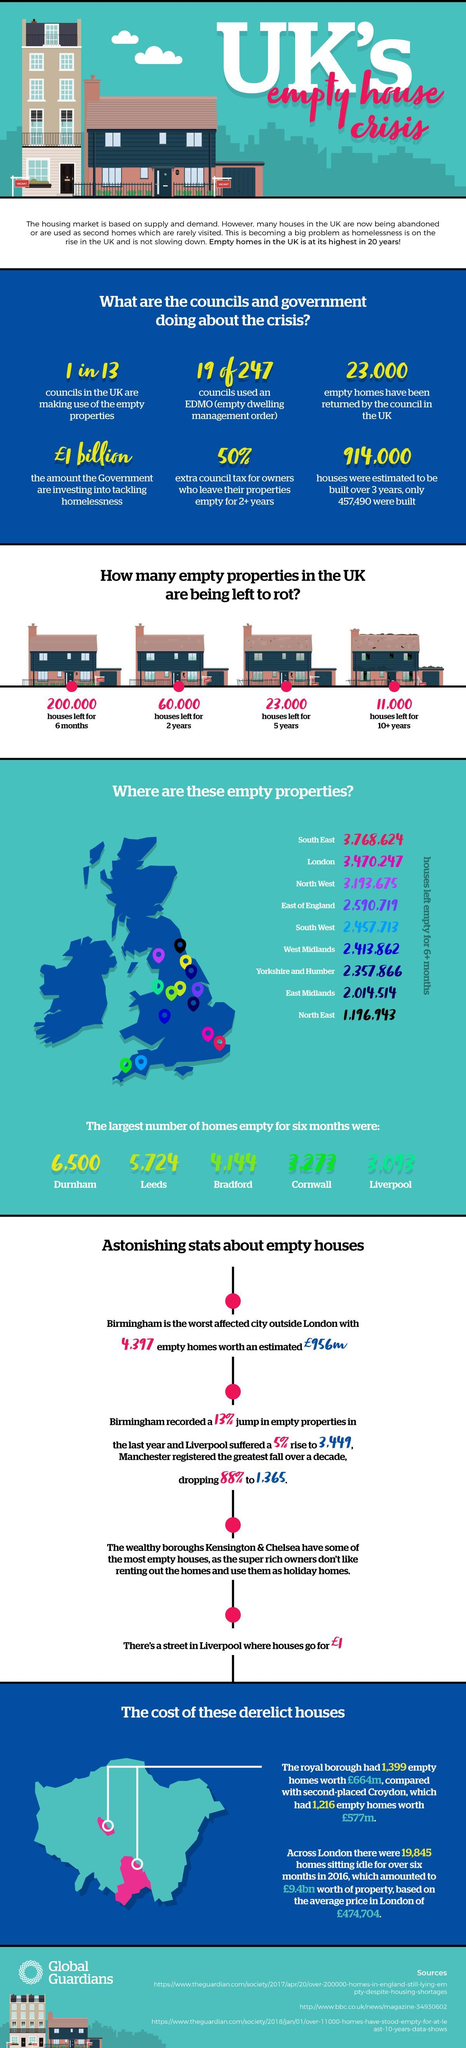How many houses in UK have been kept empty for the past 5 years?
Answer the question with a short phrase. 23,000 What are the number of houses which are left empty for the past half a year in Leeds? 5,724 Which place in UK has the fourth highest number of Empty houses? East of England Which place in UK has the second highest number of Empty houses? London What are the number of houses which are left empty for past half a year in Cornwall? 3,273 Which place in UK has the second least number of Empty houses? East Midlands What number of councils took an action plan and used empty homes in UK? 19 of 247 How many houses in UK have been kept empty for the past 2 years? 60,000 How many houses in UK have been kept empty for more than 10 years? 11,000 How many places in the Extreme south of UK has empty houses? 2 